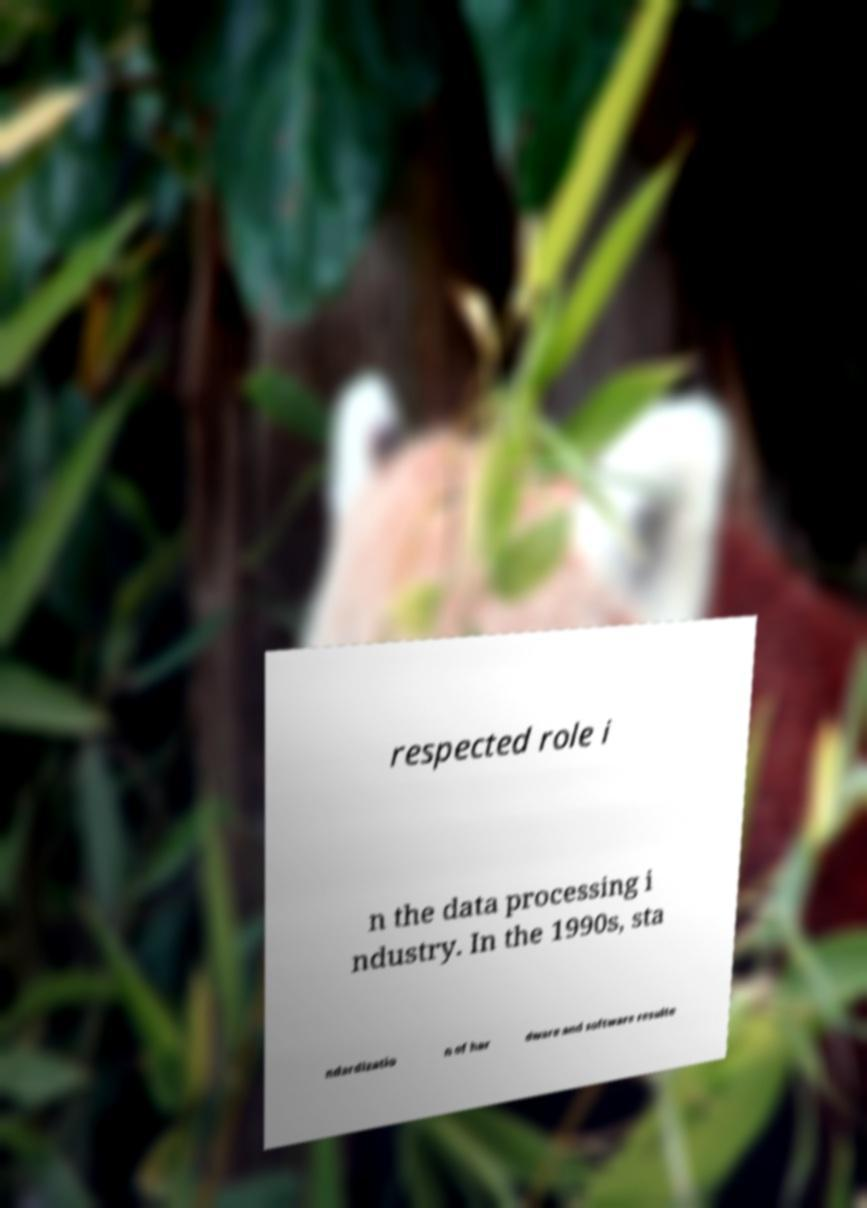Please identify and transcribe the text found in this image. respected role i n the data processing i ndustry. In the 1990s, sta ndardizatio n of har dware and software resulte 